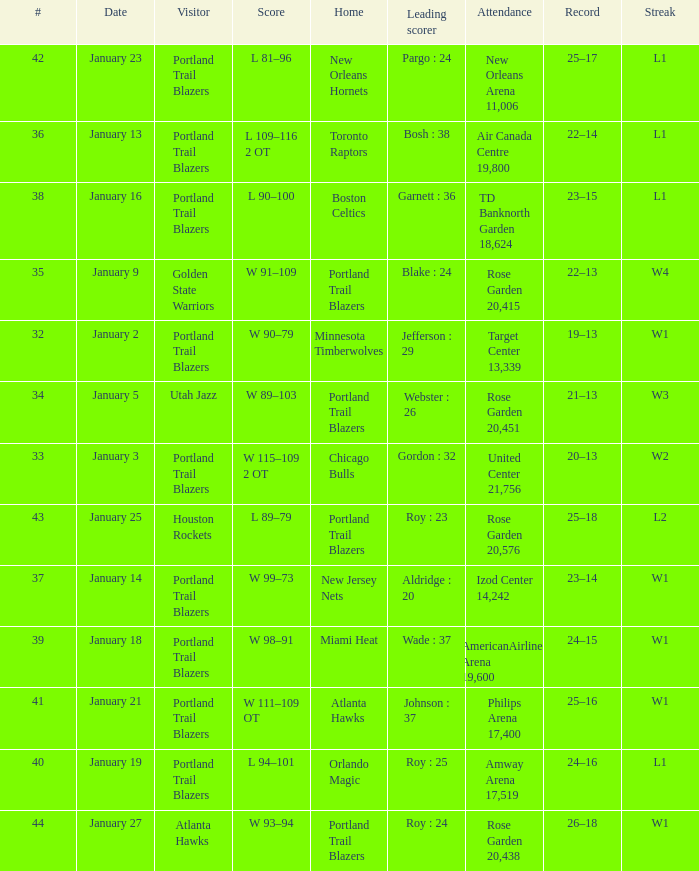What are all the records with a score is w 98–91 24–15. 